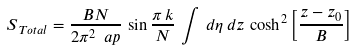Convert formula to latex. <formula><loc_0><loc_0><loc_500><loc_500>S _ { \, T o t a l } = \frac { B N } { 2 \pi ^ { 2 } \ a p } \, \sin \frac { \pi \, k } { N } \, \int \, d \eta \, d z \, \cosh ^ { 2 } \left [ \frac { z - z _ { 0 } } { B } \right ]</formula> 